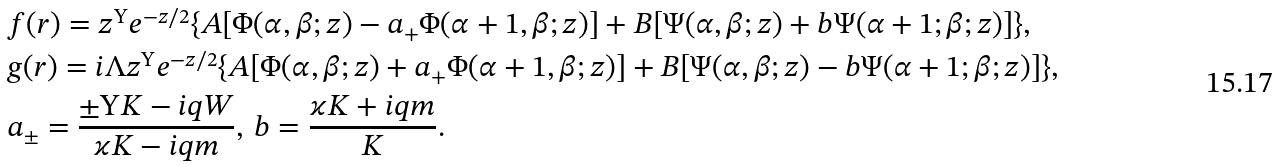Convert formula to latex. <formula><loc_0><loc_0><loc_500><loc_500>& f ( r ) = z ^ { \Upsilon } e ^ { - z / 2 } \{ A [ \Phi ( \alpha , \beta ; z ) - a _ { + } \Phi ( \alpha + 1 , \beta ; z ) ] + B [ \Psi ( \alpha , \beta ; z ) + b \Psi ( \alpha + 1 ; \beta ; z ) ] \} , \\ & g ( r ) = i \Lambda z ^ { \Upsilon } e ^ { - z / 2 } \{ A [ \Phi ( \alpha , \beta ; z ) + a _ { + } \Phi ( \alpha + 1 , \beta ; z ) ] + B [ \Psi ( \alpha , \beta ; z ) - b \Psi ( \alpha + 1 ; \beta ; z ) ] \} , \\ & a _ { \pm } = \frac { \pm \Upsilon K - i q W } { \varkappa K - i q m } , \, b = \frac { \varkappa K + i q m } { K } .</formula> 